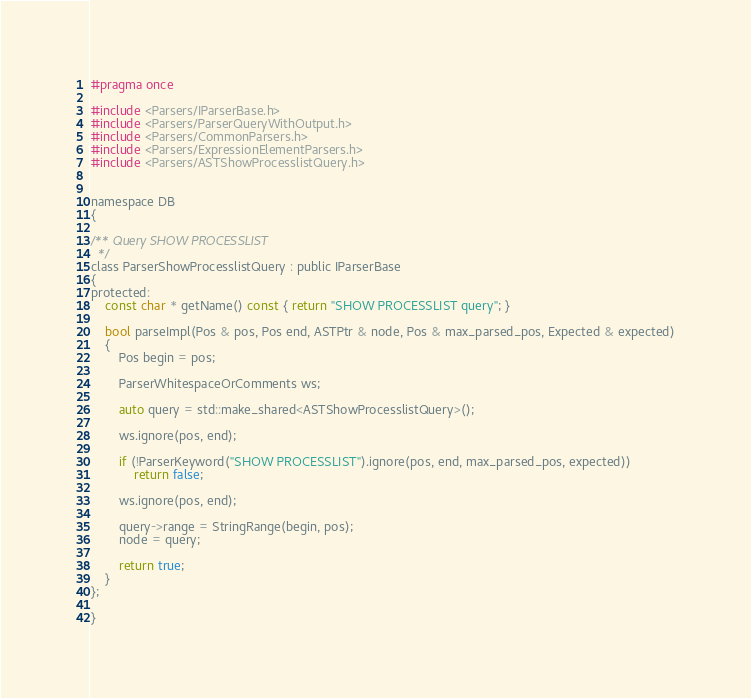Convert code to text. <code><loc_0><loc_0><loc_500><loc_500><_C_>#pragma once

#include <Parsers/IParserBase.h>
#include <Parsers/ParserQueryWithOutput.h>
#include <Parsers/CommonParsers.h>
#include <Parsers/ExpressionElementParsers.h>
#include <Parsers/ASTShowProcesslistQuery.h>


namespace DB
{

/** Query SHOW PROCESSLIST
  */
class ParserShowProcesslistQuery : public IParserBase
{
protected:
    const char * getName() const { return "SHOW PROCESSLIST query"; }

    bool parseImpl(Pos & pos, Pos end, ASTPtr & node, Pos & max_parsed_pos, Expected & expected)
    {
        Pos begin = pos;

        ParserWhitespaceOrComments ws;

        auto query = std::make_shared<ASTShowProcesslistQuery>();

        ws.ignore(pos, end);

        if (!ParserKeyword("SHOW PROCESSLIST").ignore(pos, end, max_parsed_pos, expected))
            return false;

        ws.ignore(pos, end);

        query->range = StringRange(begin, pos);
        node = query;

        return true;
    }
};

}
</code> 